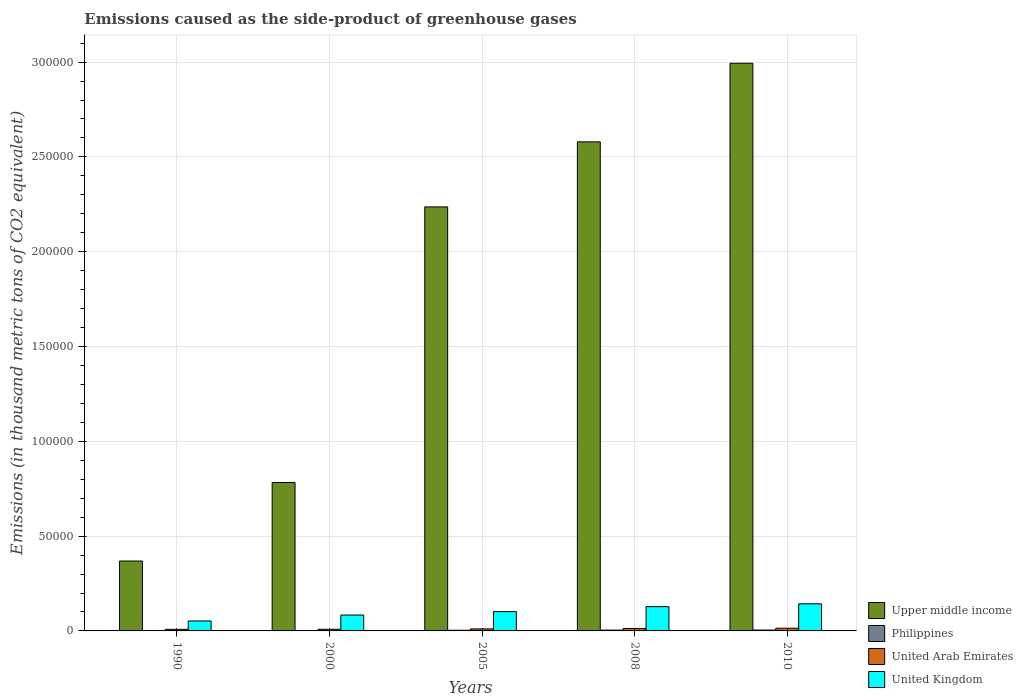How many groups of bars are there?
Provide a succinct answer. 5. How many bars are there on the 2nd tick from the right?
Your response must be concise. 4. What is the label of the 2nd group of bars from the left?
Your answer should be compact. 2000. In how many cases, is the number of bars for a given year not equal to the number of legend labels?
Give a very brief answer. 0. What is the emissions caused as the side-product of greenhouse gases in United Kingdom in 2000?
Provide a succinct answer. 8376.7. Across all years, what is the maximum emissions caused as the side-product of greenhouse gases in United Kingdom?
Keep it short and to the point. 1.43e+04. Across all years, what is the minimum emissions caused as the side-product of greenhouse gases in Upper middle income?
Offer a very short reply. 3.69e+04. In which year was the emissions caused as the side-product of greenhouse gases in Philippines maximum?
Ensure brevity in your answer.  2010. What is the total emissions caused as the side-product of greenhouse gases in Upper middle income in the graph?
Offer a terse response. 8.96e+05. What is the difference between the emissions caused as the side-product of greenhouse gases in Upper middle income in 2000 and that in 2005?
Your answer should be compact. -1.45e+05. What is the difference between the emissions caused as the side-product of greenhouse gases in United Kingdom in 2005 and the emissions caused as the side-product of greenhouse gases in Upper middle income in 1990?
Your answer should be compact. -2.67e+04. What is the average emissions caused as the side-product of greenhouse gases in Upper middle income per year?
Provide a succinct answer. 1.79e+05. In the year 1990, what is the difference between the emissions caused as the side-product of greenhouse gases in Philippines and emissions caused as the side-product of greenhouse gases in United Arab Emirates?
Keep it short and to the point. -681.5. What is the ratio of the emissions caused as the side-product of greenhouse gases in United Arab Emirates in 2000 to that in 2010?
Your answer should be very brief. 0.62. Is the emissions caused as the side-product of greenhouse gases in United Kingdom in 1990 less than that in 2010?
Your answer should be compact. Yes. What is the difference between the highest and the second highest emissions caused as the side-product of greenhouse gases in United Kingdom?
Give a very brief answer. 1493.7. What is the difference between the highest and the lowest emissions caused as the side-product of greenhouse gases in United Kingdom?
Ensure brevity in your answer.  9046.8. Is the sum of the emissions caused as the side-product of greenhouse gases in Philippines in 1990 and 2005 greater than the maximum emissions caused as the side-product of greenhouse gases in United Kingdom across all years?
Keep it short and to the point. No. Is it the case that in every year, the sum of the emissions caused as the side-product of greenhouse gases in Philippines and emissions caused as the side-product of greenhouse gases in United Arab Emirates is greater than the sum of emissions caused as the side-product of greenhouse gases in Upper middle income and emissions caused as the side-product of greenhouse gases in United Kingdom?
Provide a succinct answer. No. What does the 3rd bar from the left in 2005 represents?
Offer a very short reply. United Arab Emirates. What does the 4th bar from the right in 1990 represents?
Ensure brevity in your answer.  Upper middle income. Is it the case that in every year, the sum of the emissions caused as the side-product of greenhouse gases in Upper middle income and emissions caused as the side-product of greenhouse gases in United Kingdom is greater than the emissions caused as the side-product of greenhouse gases in Philippines?
Offer a terse response. Yes. How many years are there in the graph?
Keep it short and to the point. 5. What is the difference between two consecutive major ticks on the Y-axis?
Offer a very short reply. 5.00e+04. Are the values on the major ticks of Y-axis written in scientific E-notation?
Your answer should be compact. No. Does the graph contain any zero values?
Provide a succinct answer. No. How many legend labels are there?
Offer a terse response. 4. What is the title of the graph?
Provide a succinct answer. Emissions caused as the side-product of greenhouse gases. What is the label or title of the X-axis?
Offer a very short reply. Years. What is the label or title of the Y-axis?
Offer a very short reply. Emissions (in thousand metric tons of CO2 equivalent). What is the Emissions (in thousand metric tons of CO2 equivalent) of Upper middle income in 1990?
Give a very brief answer. 3.69e+04. What is the Emissions (in thousand metric tons of CO2 equivalent) in Philippines in 1990?
Provide a succinct answer. 161.9. What is the Emissions (in thousand metric tons of CO2 equivalent) of United Arab Emirates in 1990?
Make the answer very short. 843.4. What is the Emissions (in thousand metric tons of CO2 equivalent) of United Kingdom in 1990?
Ensure brevity in your answer.  5244.2. What is the Emissions (in thousand metric tons of CO2 equivalent) of Upper middle income in 2000?
Provide a short and direct response. 7.83e+04. What is the Emissions (in thousand metric tons of CO2 equivalent) in Philippines in 2000?
Your response must be concise. 221.4. What is the Emissions (in thousand metric tons of CO2 equivalent) in United Arab Emirates in 2000?
Provide a short and direct response. 878.1. What is the Emissions (in thousand metric tons of CO2 equivalent) of United Kingdom in 2000?
Your answer should be compact. 8376.7. What is the Emissions (in thousand metric tons of CO2 equivalent) in Upper middle income in 2005?
Provide a short and direct response. 2.24e+05. What is the Emissions (in thousand metric tons of CO2 equivalent) of Philippines in 2005?
Provide a short and direct response. 365.3. What is the Emissions (in thousand metric tons of CO2 equivalent) in United Arab Emirates in 2005?
Make the answer very short. 1064.1. What is the Emissions (in thousand metric tons of CO2 equivalent) of United Kingdom in 2005?
Your response must be concise. 1.02e+04. What is the Emissions (in thousand metric tons of CO2 equivalent) of Upper middle income in 2008?
Offer a terse response. 2.58e+05. What is the Emissions (in thousand metric tons of CO2 equivalent) in Philippines in 2008?
Give a very brief answer. 421.7. What is the Emissions (in thousand metric tons of CO2 equivalent) of United Arab Emirates in 2008?
Offer a very short reply. 1279. What is the Emissions (in thousand metric tons of CO2 equivalent) of United Kingdom in 2008?
Offer a terse response. 1.28e+04. What is the Emissions (in thousand metric tons of CO2 equivalent) of Upper middle income in 2010?
Offer a very short reply. 2.99e+05. What is the Emissions (in thousand metric tons of CO2 equivalent) of Philippines in 2010?
Make the answer very short. 459. What is the Emissions (in thousand metric tons of CO2 equivalent) in United Arab Emirates in 2010?
Offer a terse response. 1422. What is the Emissions (in thousand metric tons of CO2 equivalent) in United Kingdom in 2010?
Keep it short and to the point. 1.43e+04. Across all years, what is the maximum Emissions (in thousand metric tons of CO2 equivalent) in Upper middle income?
Your answer should be very brief. 2.99e+05. Across all years, what is the maximum Emissions (in thousand metric tons of CO2 equivalent) of Philippines?
Make the answer very short. 459. Across all years, what is the maximum Emissions (in thousand metric tons of CO2 equivalent) in United Arab Emirates?
Offer a terse response. 1422. Across all years, what is the maximum Emissions (in thousand metric tons of CO2 equivalent) of United Kingdom?
Make the answer very short. 1.43e+04. Across all years, what is the minimum Emissions (in thousand metric tons of CO2 equivalent) of Upper middle income?
Keep it short and to the point. 3.69e+04. Across all years, what is the minimum Emissions (in thousand metric tons of CO2 equivalent) of Philippines?
Offer a terse response. 161.9. Across all years, what is the minimum Emissions (in thousand metric tons of CO2 equivalent) in United Arab Emirates?
Provide a succinct answer. 843.4. Across all years, what is the minimum Emissions (in thousand metric tons of CO2 equivalent) of United Kingdom?
Offer a terse response. 5244.2. What is the total Emissions (in thousand metric tons of CO2 equivalent) of Upper middle income in the graph?
Your answer should be compact. 8.96e+05. What is the total Emissions (in thousand metric tons of CO2 equivalent) of Philippines in the graph?
Offer a terse response. 1629.3. What is the total Emissions (in thousand metric tons of CO2 equivalent) in United Arab Emirates in the graph?
Your answer should be compact. 5486.6. What is the total Emissions (in thousand metric tons of CO2 equivalent) in United Kingdom in the graph?
Offer a very short reply. 5.09e+04. What is the difference between the Emissions (in thousand metric tons of CO2 equivalent) of Upper middle income in 1990 and that in 2000?
Your response must be concise. -4.14e+04. What is the difference between the Emissions (in thousand metric tons of CO2 equivalent) in Philippines in 1990 and that in 2000?
Keep it short and to the point. -59.5. What is the difference between the Emissions (in thousand metric tons of CO2 equivalent) in United Arab Emirates in 1990 and that in 2000?
Offer a very short reply. -34.7. What is the difference between the Emissions (in thousand metric tons of CO2 equivalent) in United Kingdom in 1990 and that in 2000?
Your response must be concise. -3132.5. What is the difference between the Emissions (in thousand metric tons of CO2 equivalent) of Upper middle income in 1990 and that in 2005?
Your response must be concise. -1.87e+05. What is the difference between the Emissions (in thousand metric tons of CO2 equivalent) in Philippines in 1990 and that in 2005?
Make the answer very short. -203.4. What is the difference between the Emissions (in thousand metric tons of CO2 equivalent) in United Arab Emirates in 1990 and that in 2005?
Your response must be concise. -220.7. What is the difference between the Emissions (in thousand metric tons of CO2 equivalent) of United Kingdom in 1990 and that in 2005?
Provide a short and direct response. -4944.8. What is the difference between the Emissions (in thousand metric tons of CO2 equivalent) of Upper middle income in 1990 and that in 2008?
Provide a succinct answer. -2.21e+05. What is the difference between the Emissions (in thousand metric tons of CO2 equivalent) in Philippines in 1990 and that in 2008?
Make the answer very short. -259.8. What is the difference between the Emissions (in thousand metric tons of CO2 equivalent) of United Arab Emirates in 1990 and that in 2008?
Ensure brevity in your answer.  -435.6. What is the difference between the Emissions (in thousand metric tons of CO2 equivalent) of United Kingdom in 1990 and that in 2008?
Your answer should be compact. -7553.1. What is the difference between the Emissions (in thousand metric tons of CO2 equivalent) in Upper middle income in 1990 and that in 2010?
Ensure brevity in your answer.  -2.63e+05. What is the difference between the Emissions (in thousand metric tons of CO2 equivalent) of Philippines in 1990 and that in 2010?
Ensure brevity in your answer.  -297.1. What is the difference between the Emissions (in thousand metric tons of CO2 equivalent) in United Arab Emirates in 1990 and that in 2010?
Offer a very short reply. -578.6. What is the difference between the Emissions (in thousand metric tons of CO2 equivalent) of United Kingdom in 1990 and that in 2010?
Keep it short and to the point. -9046.8. What is the difference between the Emissions (in thousand metric tons of CO2 equivalent) in Upper middle income in 2000 and that in 2005?
Offer a very short reply. -1.45e+05. What is the difference between the Emissions (in thousand metric tons of CO2 equivalent) of Philippines in 2000 and that in 2005?
Your response must be concise. -143.9. What is the difference between the Emissions (in thousand metric tons of CO2 equivalent) in United Arab Emirates in 2000 and that in 2005?
Provide a succinct answer. -186. What is the difference between the Emissions (in thousand metric tons of CO2 equivalent) of United Kingdom in 2000 and that in 2005?
Offer a terse response. -1812.3. What is the difference between the Emissions (in thousand metric tons of CO2 equivalent) in Upper middle income in 2000 and that in 2008?
Ensure brevity in your answer.  -1.80e+05. What is the difference between the Emissions (in thousand metric tons of CO2 equivalent) in Philippines in 2000 and that in 2008?
Give a very brief answer. -200.3. What is the difference between the Emissions (in thousand metric tons of CO2 equivalent) in United Arab Emirates in 2000 and that in 2008?
Ensure brevity in your answer.  -400.9. What is the difference between the Emissions (in thousand metric tons of CO2 equivalent) of United Kingdom in 2000 and that in 2008?
Keep it short and to the point. -4420.6. What is the difference between the Emissions (in thousand metric tons of CO2 equivalent) of Upper middle income in 2000 and that in 2010?
Your answer should be compact. -2.21e+05. What is the difference between the Emissions (in thousand metric tons of CO2 equivalent) in Philippines in 2000 and that in 2010?
Offer a very short reply. -237.6. What is the difference between the Emissions (in thousand metric tons of CO2 equivalent) of United Arab Emirates in 2000 and that in 2010?
Make the answer very short. -543.9. What is the difference between the Emissions (in thousand metric tons of CO2 equivalent) in United Kingdom in 2000 and that in 2010?
Your answer should be compact. -5914.3. What is the difference between the Emissions (in thousand metric tons of CO2 equivalent) in Upper middle income in 2005 and that in 2008?
Offer a very short reply. -3.43e+04. What is the difference between the Emissions (in thousand metric tons of CO2 equivalent) of Philippines in 2005 and that in 2008?
Provide a short and direct response. -56.4. What is the difference between the Emissions (in thousand metric tons of CO2 equivalent) of United Arab Emirates in 2005 and that in 2008?
Offer a very short reply. -214.9. What is the difference between the Emissions (in thousand metric tons of CO2 equivalent) in United Kingdom in 2005 and that in 2008?
Your answer should be very brief. -2608.3. What is the difference between the Emissions (in thousand metric tons of CO2 equivalent) of Upper middle income in 2005 and that in 2010?
Give a very brief answer. -7.58e+04. What is the difference between the Emissions (in thousand metric tons of CO2 equivalent) in Philippines in 2005 and that in 2010?
Your answer should be very brief. -93.7. What is the difference between the Emissions (in thousand metric tons of CO2 equivalent) of United Arab Emirates in 2005 and that in 2010?
Offer a terse response. -357.9. What is the difference between the Emissions (in thousand metric tons of CO2 equivalent) of United Kingdom in 2005 and that in 2010?
Offer a very short reply. -4102. What is the difference between the Emissions (in thousand metric tons of CO2 equivalent) in Upper middle income in 2008 and that in 2010?
Your answer should be very brief. -4.14e+04. What is the difference between the Emissions (in thousand metric tons of CO2 equivalent) of Philippines in 2008 and that in 2010?
Your response must be concise. -37.3. What is the difference between the Emissions (in thousand metric tons of CO2 equivalent) in United Arab Emirates in 2008 and that in 2010?
Make the answer very short. -143. What is the difference between the Emissions (in thousand metric tons of CO2 equivalent) of United Kingdom in 2008 and that in 2010?
Provide a succinct answer. -1493.7. What is the difference between the Emissions (in thousand metric tons of CO2 equivalent) in Upper middle income in 1990 and the Emissions (in thousand metric tons of CO2 equivalent) in Philippines in 2000?
Ensure brevity in your answer.  3.66e+04. What is the difference between the Emissions (in thousand metric tons of CO2 equivalent) of Upper middle income in 1990 and the Emissions (in thousand metric tons of CO2 equivalent) of United Arab Emirates in 2000?
Ensure brevity in your answer.  3.60e+04. What is the difference between the Emissions (in thousand metric tons of CO2 equivalent) in Upper middle income in 1990 and the Emissions (in thousand metric tons of CO2 equivalent) in United Kingdom in 2000?
Provide a short and direct response. 2.85e+04. What is the difference between the Emissions (in thousand metric tons of CO2 equivalent) of Philippines in 1990 and the Emissions (in thousand metric tons of CO2 equivalent) of United Arab Emirates in 2000?
Provide a succinct answer. -716.2. What is the difference between the Emissions (in thousand metric tons of CO2 equivalent) in Philippines in 1990 and the Emissions (in thousand metric tons of CO2 equivalent) in United Kingdom in 2000?
Provide a short and direct response. -8214.8. What is the difference between the Emissions (in thousand metric tons of CO2 equivalent) of United Arab Emirates in 1990 and the Emissions (in thousand metric tons of CO2 equivalent) of United Kingdom in 2000?
Provide a short and direct response. -7533.3. What is the difference between the Emissions (in thousand metric tons of CO2 equivalent) in Upper middle income in 1990 and the Emissions (in thousand metric tons of CO2 equivalent) in Philippines in 2005?
Keep it short and to the point. 3.65e+04. What is the difference between the Emissions (in thousand metric tons of CO2 equivalent) in Upper middle income in 1990 and the Emissions (in thousand metric tons of CO2 equivalent) in United Arab Emirates in 2005?
Provide a short and direct response. 3.58e+04. What is the difference between the Emissions (in thousand metric tons of CO2 equivalent) of Upper middle income in 1990 and the Emissions (in thousand metric tons of CO2 equivalent) of United Kingdom in 2005?
Your response must be concise. 2.67e+04. What is the difference between the Emissions (in thousand metric tons of CO2 equivalent) of Philippines in 1990 and the Emissions (in thousand metric tons of CO2 equivalent) of United Arab Emirates in 2005?
Give a very brief answer. -902.2. What is the difference between the Emissions (in thousand metric tons of CO2 equivalent) of Philippines in 1990 and the Emissions (in thousand metric tons of CO2 equivalent) of United Kingdom in 2005?
Keep it short and to the point. -1.00e+04. What is the difference between the Emissions (in thousand metric tons of CO2 equivalent) of United Arab Emirates in 1990 and the Emissions (in thousand metric tons of CO2 equivalent) of United Kingdom in 2005?
Your response must be concise. -9345.6. What is the difference between the Emissions (in thousand metric tons of CO2 equivalent) in Upper middle income in 1990 and the Emissions (in thousand metric tons of CO2 equivalent) in Philippines in 2008?
Give a very brief answer. 3.64e+04. What is the difference between the Emissions (in thousand metric tons of CO2 equivalent) of Upper middle income in 1990 and the Emissions (in thousand metric tons of CO2 equivalent) of United Arab Emirates in 2008?
Your answer should be compact. 3.56e+04. What is the difference between the Emissions (in thousand metric tons of CO2 equivalent) in Upper middle income in 1990 and the Emissions (in thousand metric tons of CO2 equivalent) in United Kingdom in 2008?
Ensure brevity in your answer.  2.41e+04. What is the difference between the Emissions (in thousand metric tons of CO2 equivalent) in Philippines in 1990 and the Emissions (in thousand metric tons of CO2 equivalent) in United Arab Emirates in 2008?
Give a very brief answer. -1117.1. What is the difference between the Emissions (in thousand metric tons of CO2 equivalent) in Philippines in 1990 and the Emissions (in thousand metric tons of CO2 equivalent) in United Kingdom in 2008?
Give a very brief answer. -1.26e+04. What is the difference between the Emissions (in thousand metric tons of CO2 equivalent) in United Arab Emirates in 1990 and the Emissions (in thousand metric tons of CO2 equivalent) in United Kingdom in 2008?
Ensure brevity in your answer.  -1.20e+04. What is the difference between the Emissions (in thousand metric tons of CO2 equivalent) in Upper middle income in 1990 and the Emissions (in thousand metric tons of CO2 equivalent) in Philippines in 2010?
Provide a short and direct response. 3.64e+04. What is the difference between the Emissions (in thousand metric tons of CO2 equivalent) of Upper middle income in 1990 and the Emissions (in thousand metric tons of CO2 equivalent) of United Arab Emirates in 2010?
Your answer should be very brief. 3.54e+04. What is the difference between the Emissions (in thousand metric tons of CO2 equivalent) of Upper middle income in 1990 and the Emissions (in thousand metric tons of CO2 equivalent) of United Kingdom in 2010?
Provide a short and direct response. 2.26e+04. What is the difference between the Emissions (in thousand metric tons of CO2 equivalent) in Philippines in 1990 and the Emissions (in thousand metric tons of CO2 equivalent) in United Arab Emirates in 2010?
Ensure brevity in your answer.  -1260.1. What is the difference between the Emissions (in thousand metric tons of CO2 equivalent) of Philippines in 1990 and the Emissions (in thousand metric tons of CO2 equivalent) of United Kingdom in 2010?
Offer a terse response. -1.41e+04. What is the difference between the Emissions (in thousand metric tons of CO2 equivalent) of United Arab Emirates in 1990 and the Emissions (in thousand metric tons of CO2 equivalent) of United Kingdom in 2010?
Provide a short and direct response. -1.34e+04. What is the difference between the Emissions (in thousand metric tons of CO2 equivalent) of Upper middle income in 2000 and the Emissions (in thousand metric tons of CO2 equivalent) of Philippines in 2005?
Your answer should be very brief. 7.79e+04. What is the difference between the Emissions (in thousand metric tons of CO2 equivalent) in Upper middle income in 2000 and the Emissions (in thousand metric tons of CO2 equivalent) in United Arab Emirates in 2005?
Provide a succinct answer. 7.72e+04. What is the difference between the Emissions (in thousand metric tons of CO2 equivalent) in Upper middle income in 2000 and the Emissions (in thousand metric tons of CO2 equivalent) in United Kingdom in 2005?
Your answer should be compact. 6.81e+04. What is the difference between the Emissions (in thousand metric tons of CO2 equivalent) in Philippines in 2000 and the Emissions (in thousand metric tons of CO2 equivalent) in United Arab Emirates in 2005?
Provide a short and direct response. -842.7. What is the difference between the Emissions (in thousand metric tons of CO2 equivalent) of Philippines in 2000 and the Emissions (in thousand metric tons of CO2 equivalent) of United Kingdom in 2005?
Provide a succinct answer. -9967.6. What is the difference between the Emissions (in thousand metric tons of CO2 equivalent) of United Arab Emirates in 2000 and the Emissions (in thousand metric tons of CO2 equivalent) of United Kingdom in 2005?
Your answer should be compact. -9310.9. What is the difference between the Emissions (in thousand metric tons of CO2 equivalent) of Upper middle income in 2000 and the Emissions (in thousand metric tons of CO2 equivalent) of Philippines in 2008?
Offer a terse response. 7.79e+04. What is the difference between the Emissions (in thousand metric tons of CO2 equivalent) of Upper middle income in 2000 and the Emissions (in thousand metric tons of CO2 equivalent) of United Arab Emirates in 2008?
Ensure brevity in your answer.  7.70e+04. What is the difference between the Emissions (in thousand metric tons of CO2 equivalent) in Upper middle income in 2000 and the Emissions (in thousand metric tons of CO2 equivalent) in United Kingdom in 2008?
Give a very brief answer. 6.55e+04. What is the difference between the Emissions (in thousand metric tons of CO2 equivalent) of Philippines in 2000 and the Emissions (in thousand metric tons of CO2 equivalent) of United Arab Emirates in 2008?
Make the answer very short. -1057.6. What is the difference between the Emissions (in thousand metric tons of CO2 equivalent) of Philippines in 2000 and the Emissions (in thousand metric tons of CO2 equivalent) of United Kingdom in 2008?
Keep it short and to the point. -1.26e+04. What is the difference between the Emissions (in thousand metric tons of CO2 equivalent) of United Arab Emirates in 2000 and the Emissions (in thousand metric tons of CO2 equivalent) of United Kingdom in 2008?
Your answer should be compact. -1.19e+04. What is the difference between the Emissions (in thousand metric tons of CO2 equivalent) of Upper middle income in 2000 and the Emissions (in thousand metric tons of CO2 equivalent) of Philippines in 2010?
Your answer should be compact. 7.78e+04. What is the difference between the Emissions (in thousand metric tons of CO2 equivalent) in Upper middle income in 2000 and the Emissions (in thousand metric tons of CO2 equivalent) in United Arab Emirates in 2010?
Your answer should be very brief. 7.69e+04. What is the difference between the Emissions (in thousand metric tons of CO2 equivalent) of Upper middle income in 2000 and the Emissions (in thousand metric tons of CO2 equivalent) of United Kingdom in 2010?
Give a very brief answer. 6.40e+04. What is the difference between the Emissions (in thousand metric tons of CO2 equivalent) in Philippines in 2000 and the Emissions (in thousand metric tons of CO2 equivalent) in United Arab Emirates in 2010?
Offer a terse response. -1200.6. What is the difference between the Emissions (in thousand metric tons of CO2 equivalent) of Philippines in 2000 and the Emissions (in thousand metric tons of CO2 equivalent) of United Kingdom in 2010?
Offer a very short reply. -1.41e+04. What is the difference between the Emissions (in thousand metric tons of CO2 equivalent) of United Arab Emirates in 2000 and the Emissions (in thousand metric tons of CO2 equivalent) of United Kingdom in 2010?
Provide a succinct answer. -1.34e+04. What is the difference between the Emissions (in thousand metric tons of CO2 equivalent) in Upper middle income in 2005 and the Emissions (in thousand metric tons of CO2 equivalent) in Philippines in 2008?
Provide a short and direct response. 2.23e+05. What is the difference between the Emissions (in thousand metric tons of CO2 equivalent) of Upper middle income in 2005 and the Emissions (in thousand metric tons of CO2 equivalent) of United Arab Emirates in 2008?
Give a very brief answer. 2.22e+05. What is the difference between the Emissions (in thousand metric tons of CO2 equivalent) of Upper middle income in 2005 and the Emissions (in thousand metric tons of CO2 equivalent) of United Kingdom in 2008?
Provide a succinct answer. 2.11e+05. What is the difference between the Emissions (in thousand metric tons of CO2 equivalent) in Philippines in 2005 and the Emissions (in thousand metric tons of CO2 equivalent) in United Arab Emirates in 2008?
Ensure brevity in your answer.  -913.7. What is the difference between the Emissions (in thousand metric tons of CO2 equivalent) in Philippines in 2005 and the Emissions (in thousand metric tons of CO2 equivalent) in United Kingdom in 2008?
Your response must be concise. -1.24e+04. What is the difference between the Emissions (in thousand metric tons of CO2 equivalent) of United Arab Emirates in 2005 and the Emissions (in thousand metric tons of CO2 equivalent) of United Kingdom in 2008?
Offer a very short reply. -1.17e+04. What is the difference between the Emissions (in thousand metric tons of CO2 equivalent) of Upper middle income in 2005 and the Emissions (in thousand metric tons of CO2 equivalent) of Philippines in 2010?
Keep it short and to the point. 2.23e+05. What is the difference between the Emissions (in thousand metric tons of CO2 equivalent) in Upper middle income in 2005 and the Emissions (in thousand metric tons of CO2 equivalent) in United Arab Emirates in 2010?
Give a very brief answer. 2.22e+05. What is the difference between the Emissions (in thousand metric tons of CO2 equivalent) of Upper middle income in 2005 and the Emissions (in thousand metric tons of CO2 equivalent) of United Kingdom in 2010?
Offer a terse response. 2.09e+05. What is the difference between the Emissions (in thousand metric tons of CO2 equivalent) in Philippines in 2005 and the Emissions (in thousand metric tons of CO2 equivalent) in United Arab Emirates in 2010?
Give a very brief answer. -1056.7. What is the difference between the Emissions (in thousand metric tons of CO2 equivalent) in Philippines in 2005 and the Emissions (in thousand metric tons of CO2 equivalent) in United Kingdom in 2010?
Your response must be concise. -1.39e+04. What is the difference between the Emissions (in thousand metric tons of CO2 equivalent) of United Arab Emirates in 2005 and the Emissions (in thousand metric tons of CO2 equivalent) of United Kingdom in 2010?
Provide a succinct answer. -1.32e+04. What is the difference between the Emissions (in thousand metric tons of CO2 equivalent) of Upper middle income in 2008 and the Emissions (in thousand metric tons of CO2 equivalent) of Philippines in 2010?
Offer a very short reply. 2.57e+05. What is the difference between the Emissions (in thousand metric tons of CO2 equivalent) in Upper middle income in 2008 and the Emissions (in thousand metric tons of CO2 equivalent) in United Arab Emirates in 2010?
Your response must be concise. 2.57e+05. What is the difference between the Emissions (in thousand metric tons of CO2 equivalent) in Upper middle income in 2008 and the Emissions (in thousand metric tons of CO2 equivalent) in United Kingdom in 2010?
Keep it short and to the point. 2.44e+05. What is the difference between the Emissions (in thousand metric tons of CO2 equivalent) of Philippines in 2008 and the Emissions (in thousand metric tons of CO2 equivalent) of United Arab Emirates in 2010?
Provide a short and direct response. -1000.3. What is the difference between the Emissions (in thousand metric tons of CO2 equivalent) in Philippines in 2008 and the Emissions (in thousand metric tons of CO2 equivalent) in United Kingdom in 2010?
Offer a terse response. -1.39e+04. What is the difference between the Emissions (in thousand metric tons of CO2 equivalent) in United Arab Emirates in 2008 and the Emissions (in thousand metric tons of CO2 equivalent) in United Kingdom in 2010?
Provide a short and direct response. -1.30e+04. What is the average Emissions (in thousand metric tons of CO2 equivalent) in Upper middle income per year?
Offer a terse response. 1.79e+05. What is the average Emissions (in thousand metric tons of CO2 equivalent) in Philippines per year?
Your response must be concise. 325.86. What is the average Emissions (in thousand metric tons of CO2 equivalent) of United Arab Emirates per year?
Your answer should be very brief. 1097.32. What is the average Emissions (in thousand metric tons of CO2 equivalent) of United Kingdom per year?
Offer a very short reply. 1.02e+04. In the year 1990, what is the difference between the Emissions (in thousand metric tons of CO2 equivalent) in Upper middle income and Emissions (in thousand metric tons of CO2 equivalent) in Philippines?
Provide a succinct answer. 3.67e+04. In the year 1990, what is the difference between the Emissions (in thousand metric tons of CO2 equivalent) of Upper middle income and Emissions (in thousand metric tons of CO2 equivalent) of United Arab Emirates?
Offer a very short reply. 3.60e+04. In the year 1990, what is the difference between the Emissions (in thousand metric tons of CO2 equivalent) of Upper middle income and Emissions (in thousand metric tons of CO2 equivalent) of United Kingdom?
Your answer should be very brief. 3.16e+04. In the year 1990, what is the difference between the Emissions (in thousand metric tons of CO2 equivalent) in Philippines and Emissions (in thousand metric tons of CO2 equivalent) in United Arab Emirates?
Your answer should be compact. -681.5. In the year 1990, what is the difference between the Emissions (in thousand metric tons of CO2 equivalent) in Philippines and Emissions (in thousand metric tons of CO2 equivalent) in United Kingdom?
Your response must be concise. -5082.3. In the year 1990, what is the difference between the Emissions (in thousand metric tons of CO2 equivalent) of United Arab Emirates and Emissions (in thousand metric tons of CO2 equivalent) of United Kingdom?
Your answer should be compact. -4400.8. In the year 2000, what is the difference between the Emissions (in thousand metric tons of CO2 equivalent) of Upper middle income and Emissions (in thousand metric tons of CO2 equivalent) of Philippines?
Your answer should be very brief. 7.81e+04. In the year 2000, what is the difference between the Emissions (in thousand metric tons of CO2 equivalent) of Upper middle income and Emissions (in thousand metric tons of CO2 equivalent) of United Arab Emirates?
Ensure brevity in your answer.  7.74e+04. In the year 2000, what is the difference between the Emissions (in thousand metric tons of CO2 equivalent) in Upper middle income and Emissions (in thousand metric tons of CO2 equivalent) in United Kingdom?
Your response must be concise. 6.99e+04. In the year 2000, what is the difference between the Emissions (in thousand metric tons of CO2 equivalent) of Philippines and Emissions (in thousand metric tons of CO2 equivalent) of United Arab Emirates?
Ensure brevity in your answer.  -656.7. In the year 2000, what is the difference between the Emissions (in thousand metric tons of CO2 equivalent) in Philippines and Emissions (in thousand metric tons of CO2 equivalent) in United Kingdom?
Your answer should be compact. -8155.3. In the year 2000, what is the difference between the Emissions (in thousand metric tons of CO2 equivalent) of United Arab Emirates and Emissions (in thousand metric tons of CO2 equivalent) of United Kingdom?
Keep it short and to the point. -7498.6. In the year 2005, what is the difference between the Emissions (in thousand metric tons of CO2 equivalent) in Upper middle income and Emissions (in thousand metric tons of CO2 equivalent) in Philippines?
Your answer should be very brief. 2.23e+05. In the year 2005, what is the difference between the Emissions (in thousand metric tons of CO2 equivalent) in Upper middle income and Emissions (in thousand metric tons of CO2 equivalent) in United Arab Emirates?
Provide a succinct answer. 2.23e+05. In the year 2005, what is the difference between the Emissions (in thousand metric tons of CO2 equivalent) of Upper middle income and Emissions (in thousand metric tons of CO2 equivalent) of United Kingdom?
Your answer should be very brief. 2.13e+05. In the year 2005, what is the difference between the Emissions (in thousand metric tons of CO2 equivalent) in Philippines and Emissions (in thousand metric tons of CO2 equivalent) in United Arab Emirates?
Make the answer very short. -698.8. In the year 2005, what is the difference between the Emissions (in thousand metric tons of CO2 equivalent) of Philippines and Emissions (in thousand metric tons of CO2 equivalent) of United Kingdom?
Your answer should be very brief. -9823.7. In the year 2005, what is the difference between the Emissions (in thousand metric tons of CO2 equivalent) in United Arab Emirates and Emissions (in thousand metric tons of CO2 equivalent) in United Kingdom?
Ensure brevity in your answer.  -9124.9. In the year 2008, what is the difference between the Emissions (in thousand metric tons of CO2 equivalent) in Upper middle income and Emissions (in thousand metric tons of CO2 equivalent) in Philippines?
Ensure brevity in your answer.  2.58e+05. In the year 2008, what is the difference between the Emissions (in thousand metric tons of CO2 equivalent) of Upper middle income and Emissions (in thousand metric tons of CO2 equivalent) of United Arab Emirates?
Offer a terse response. 2.57e+05. In the year 2008, what is the difference between the Emissions (in thousand metric tons of CO2 equivalent) in Upper middle income and Emissions (in thousand metric tons of CO2 equivalent) in United Kingdom?
Offer a terse response. 2.45e+05. In the year 2008, what is the difference between the Emissions (in thousand metric tons of CO2 equivalent) of Philippines and Emissions (in thousand metric tons of CO2 equivalent) of United Arab Emirates?
Provide a succinct answer. -857.3. In the year 2008, what is the difference between the Emissions (in thousand metric tons of CO2 equivalent) in Philippines and Emissions (in thousand metric tons of CO2 equivalent) in United Kingdom?
Your answer should be very brief. -1.24e+04. In the year 2008, what is the difference between the Emissions (in thousand metric tons of CO2 equivalent) of United Arab Emirates and Emissions (in thousand metric tons of CO2 equivalent) of United Kingdom?
Keep it short and to the point. -1.15e+04. In the year 2010, what is the difference between the Emissions (in thousand metric tons of CO2 equivalent) of Upper middle income and Emissions (in thousand metric tons of CO2 equivalent) of Philippines?
Offer a terse response. 2.99e+05. In the year 2010, what is the difference between the Emissions (in thousand metric tons of CO2 equivalent) of Upper middle income and Emissions (in thousand metric tons of CO2 equivalent) of United Arab Emirates?
Offer a terse response. 2.98e+05. In the year 2010, what is the difference between the Emissions (in thousand metric tons of CO2 equivalent) in Upper middle income and Emissions (in thousand metric tons of CO2 equivalent) in United Kingdom?
Your answer should be compact. 2.85e+05. In the year 2010, what is the difference between the Emissions (in thousand metric tons of CO2 equivalent) of Philippines and Emissions (in thousand metric tons of CO2 equivalent) of United Arab Emirates?
Your answer should be compact. -963. In the year 2010, what is the difference between the Emissions (in thousand metric tons of CO2 equivalent) in Philippines and Emissions (in thousand metric tons of CO2 equivalent) in United Kingdom?
Offer a terse response. -1.38e+04. In the year 2010, what is the difference between the Emissions (in thousand metric tons of CO2 equivalent) of United Arab Emirates and Emissions (in thousand metric tons of CO2 equivalent) of United Kingdom?
Offer a very short reply. -1.29e+04. What is the ratio of the Emissions (in thousand metric tons of CO2 equivalent) of Upper middle income in 1990 to that in 2000?
Offer a terse response. 0.47. What is the ratio of the Emissions (in thousand metric tons of CO2 equivalent) of Philippines in 1990 to that in 2000?
Ensure brevity in your answer.  0.73. What is the ratio of the Emissions (in thousand metric tons of CO2 equivalent) in United Arab Emirates in 1990 to that in 2000?
Your answer should be compact. 0.96. What is the ratio of the Emissions (in thousand metric tons of CO2 equivalent) of United Kingdom in 1990 to that in 2000?
Offer a very short reply. 0.63. What is the ratio of the Emissions (in thousand metric tons of CO2 equivalent) in Upper middle income in 1990 to that in 2005?
Offer a very short reply. 0.16. What is the ratio of the Emissions (in thousand metric tons of CO2 equivalent) in Philippines in 1990 to that in 2005?
Make the answer very short. 0.44. What is the ratio of the Emissions (in thousand metric tons of CO2 equivalent) in United Arab Emirates in 1990 to that in 2005?
Ensure brevity in your answer.  0.79. What is the ratio of the Emissions (in thousand metric tons of CO2 equivalent) of United Kingdom in 1990 to that in 2005?
Ensure brevity in your answer.  0.51. What is the ratio of the Emissions (in thousand metric tons of CO2 equivalent) in Upper middle income in 1990 to that in 2008?
Provide a short and direct response. 0.14. What is the ratio of the Emissions (in thousand metric tons of CO2 equivalent) in Philippines in 1990 to that in 2008?
Ensure brevity in your answer.  0.38. What is the ratio of the Emissions (in thousand metric tons of CO2 equivalent) in United Arab Emirates in 1990 to that in 2008?
Provide a short and direct response. 0.66. What is the ratio of the Emissions (in thousand metric tons of CO2 equivalent) in United Kingdom in 1990 to that in 2008?
Offer a very short reply. 0.41. What is the ratio of the Emissions (in thousand metric tons of CO2 equivalent) of Upper middle income in 1990 to that in 2010?
Your answer should be compact. 0.12. What is the ratio of the Emissions (in thousand metric tons of CO2 equivalent) in Philippines in 1990 to that in 2010?
Ensure brevity in your answer.  0.35. What is the ratio of the Emissions (in thousand metric tons of CO2 equivalent) of United Arab Emirates in 1990 to that in 2010?
Your answer should be very brief. 0.59. What is the ratio of the Emissions (in thousand metric tons of CO2 equivalent) of United Kingdom in 1990 to that in 2010?
Ensure brevity in your answer.  0.37. What is the ratio of the Emissions (in thousand metric tons of CO2 equivalent) of Philippines in 2000 to that in 2005?
Keep it short and to the point. 0.61. What is the ratio of the Emissions (in thousand metric tons of CO2 equivalent) of United Arab Emirates in 2000 to that in 2005?
Give a very brief answer. 0.83. What is the ratio of the Emissions (in thousand metric tons of CO2 equivalent) in United Kingdom in 2000 to that in 2005?
Offer a very short reply. 0.82. What is the ratio of the Emissions (in thousand metric tons of CO2 equivalent) in Upper middle income in 2000 to that in 2008?
Provide a succinct answer. 0.3. What is the ratio of the Emissions (in thousand metric tons of CO2 equivalent) in Philippines in 2000 to that in 2008?
Offer a very short reply. 0.53. What is the ratio of the Emissions (in thousand metric tons of CO2 equivalent) of United Arab Emirates in 2000 to that in 2008?
Your response must be concise. 0.69. What is the ratio of the Emissions (in thousand metric tons of CO2 equivalent) of United Kingdom in 2000 to that in 2008?
Provide a short and direct response. 0.65. What is the ratio of the Emissions (in thousand metric tons of CO2 equivalent) in Upper middle income in 2000 to that in 2010?
Your answer should be very brief. 0.26. What is the ratio of the Emissions (in thousand metric tons of CO2 equivalent) of Philippines in 2000 to that in 2010?
Keep it short and to the point. 0.48. What is the ratio of the Emissions (in thousand metric tons of CO2 equivalent) in United Arab Emirates in 2000 to that in 2010?
Make the answer very short. 0.62. What is the ratio of the Emissions (in thousand metric tons of CO2 equivalent) of United Kingdom in 2000 to that in 2010?
Your response must be concise. 0.59. What is the ratio of the Emissions (in thousand metric tons of CO2 equivalent) of Upper middle income in 2005 to that in 2008?
Offer a terse response. 0.87. What is the ratio of the Emissions (in thousand metric tons of CO2 equivalent) of Philippines in 2005 to that in 2008?
Ensure brevity in your answer.  0.87. What is the ratio of the Emissions (in thousand metric tons of CO2 equivalent) in United Arab Emirates in 2005 to that in 2008?
Offer a terse response. 0.83. What is the ratio of the Emissions (in thousand metric tons of CO2 equivalent) of United Kingdom in 2005 to that in 2008?
Offer a terse response. 0.8. What is the ratio of the Emissions (in thousand metric tons of CO2 equivalent) in Upper middle income in 2005 to that in 2010?
Offer a very short reply. 0.75. What is the ratio of the Emissions (in thousand metric tons of CO2 equivalent) in Philippines in 2005 to that in 2010?
Your answer should be very brief. 0.8. What is the ratio of the Emissions (in thousand metric tons of CO2 equivalent) of United Arab Emirates in 2005 to that in 2010?
Provide a succinct answer. 0.75. What is the ratio of the Emissions (in thousand metric tons of CO2 equivalent) of United Kingdom in 2005 to that in 2010?
Make the answer very short. 0.71. What is the ratio of the Emissions (in thousand metric tons of CO2 equivalent) of Upper middle income in 2008 to that in 2010?
Offer a terse response. 0.86. What is the ratio of the Emissions (in thousand metric tons of CO2 equivalent) of Philippines in 2008 to that in 2010?
Your response must be concise. 0.92. What is the ratio of the Emissions (in thousand metric tons of CO2 equivalent) in United Arab Emirates in 2008 to that in 2010?
Your response must be concise. 0.9. What is the ratio of the Emissions (in thousand metric tons of CO2 equivalent) in United Kingdom in 2008 to that in 2010?
Ensure brevity in your answer.  0.9. What is the difference between the highest and the second highest Emissions (in thousand metric tons of CO2 equivalent) of Upper middle income?
Provide a succinct answer. 4.14e+04. What is the difference between the highest and the second highest Emissions (in thousand metric tons of CO2 equivalent) in Philippines?
Keep it short and to the point. 37.3. What is the difference between the highest and the second highest Emissions (in thousand metric tons of CO2 equivalent) in United Arab Emirates?
Your answer should be very brief. 143. What is the difference between the highest and the second highest Emissions (in thousand metric tons of CO2 equivalent) of United Kingdom?
Offer a terse response. 1493.7. What is the difference between the highest and the lowest Emissions (in thousand metric tons of CO2 equivalent) of Upper middle income?
Make the answer very short. 2.63e+05. What is the difference between the highest and the lowest Emissions (in thousand metric tons of CO2 equivalent) of Philippines?
Keep it short and to the point. 297.1. What is the difference between the highest and the lowest Emissions (in thousand metric tons of CO2 equivalent) in United Arab Emirates?
Offer a very short reply. 578.6. What is the difference between the highest and the lowest Emissions (in thousand metric tons of CO2 equivalent) in United Kingdom?
Provide a succinct answer. 9046.8. 